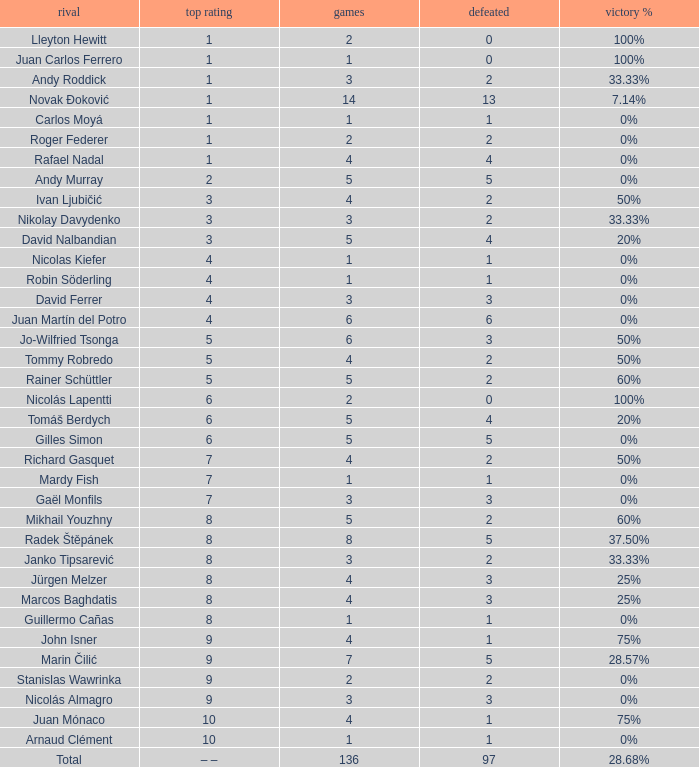What is the largest number Lost to david nalbandian with a Win Rate of 20%? 4.0. 